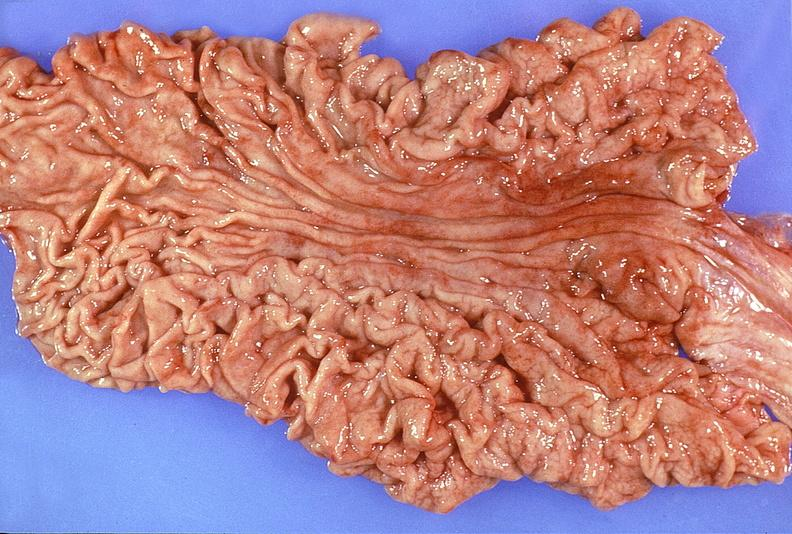what is present?
Answer the question using a single word or phrase. Gastrointestinal 